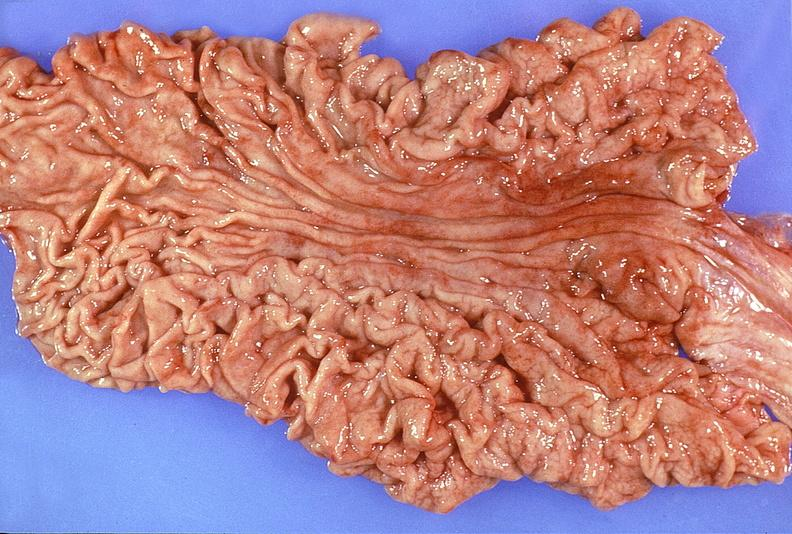what is present?
Answer the question using a single word or phrase. Gastrointestinal 